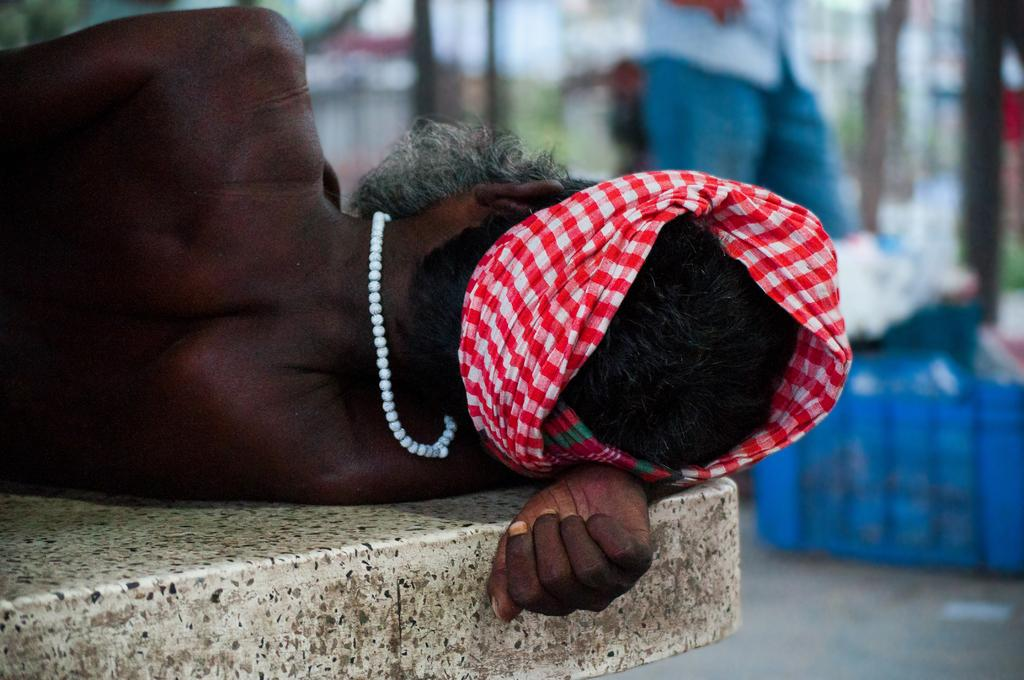What is the main subject in the foreground of the image? There is a person laying in the foreground of the image. What can be seen in the background of the image? There are other persons, poles, houses, and boxes visible in the background of the image. How many people are present in the image? There is at least one person in the foreground and others in the background, so there are multiple people present. What type of structures are visible in the background? Houses are visible in the background of the image. What type of cheese is being added to the poles in the image? There is no cheese present in the image, nor is there any indication of addition or modification to the poles. 